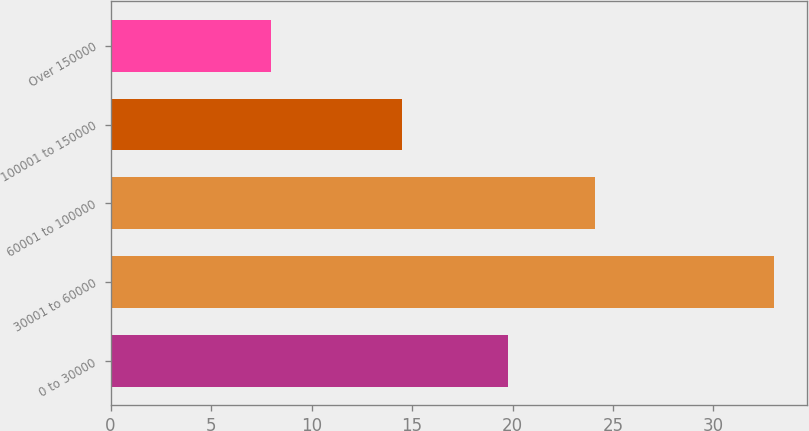<chart> <loc_0><loc_0><loc_500><loc_500><bar_chart><fcel>0 to 30000<fcel>30001 to 60000<fcel>60001 to 100000<fcel>100001 to 150000<fcel>Over 150000<nl><fcel>19.8<fcel>33<fcel>24.1<fcel>14.5<fcel>8<nl></chart> 